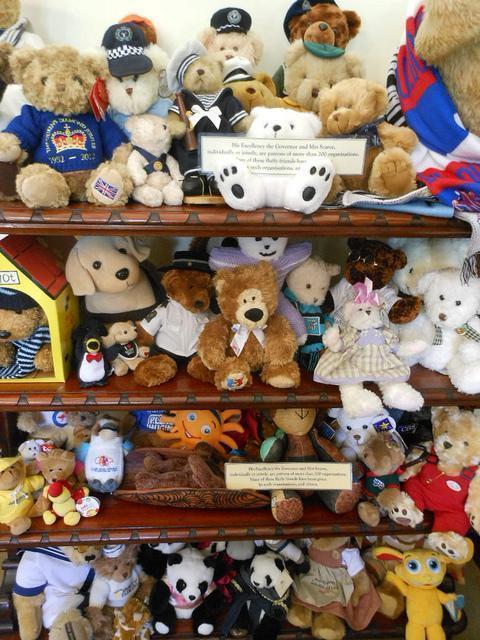What does the person who owns the shelves like to collect?
Indicate the correct response and explain using: 'Answer: answer
Rationale: rationale.'
Options: Stuffed animals, clothing, books, games. Answer: stuffed animals.
Rationale: The person who owns the shelves is collecting a number of stuffed animals there. 